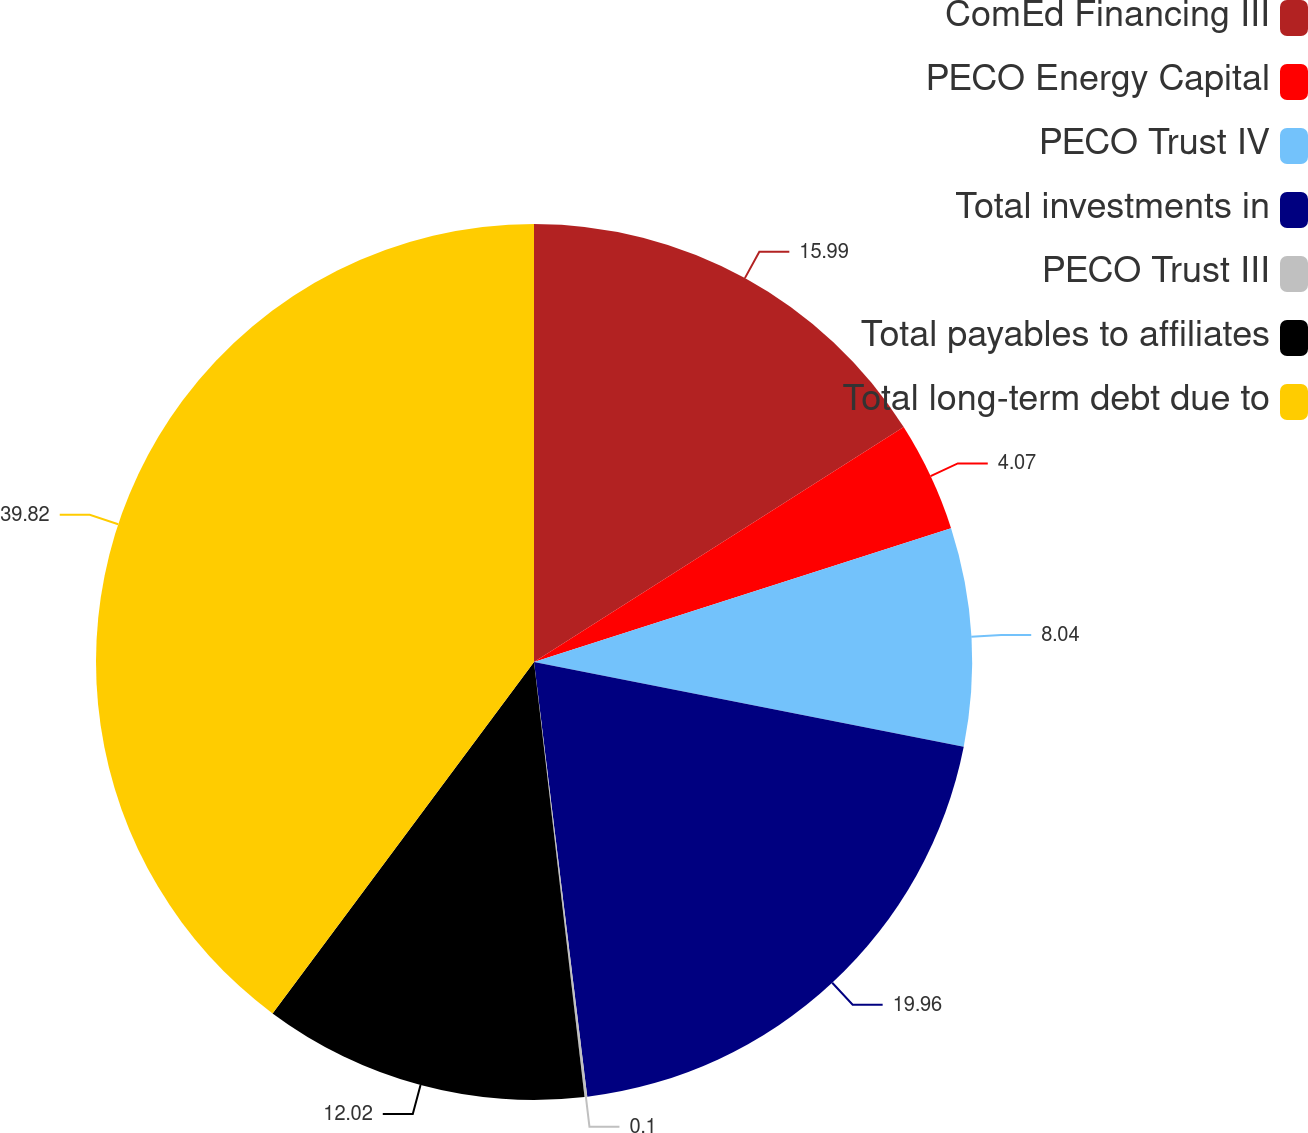Convert chart to OTSL. <chart><loc_0><loc_0><loc_500><loc_500><pie_chart><fcel>ComEd Financing III<fcel>PECO Energy Capital<fcel>PECO Trust IV<fcel>Total investments in<fcel>PECO Trust III<fcel>Total payables to affiliates<fcel>Total long-term debt due to<nl><fcel>15.99%<fcel>4.07%<fcel>8.04%<fcel>19.96%<fcel>0.1%<fcel>12.02%<fcel>39.82%<nl></chart> 